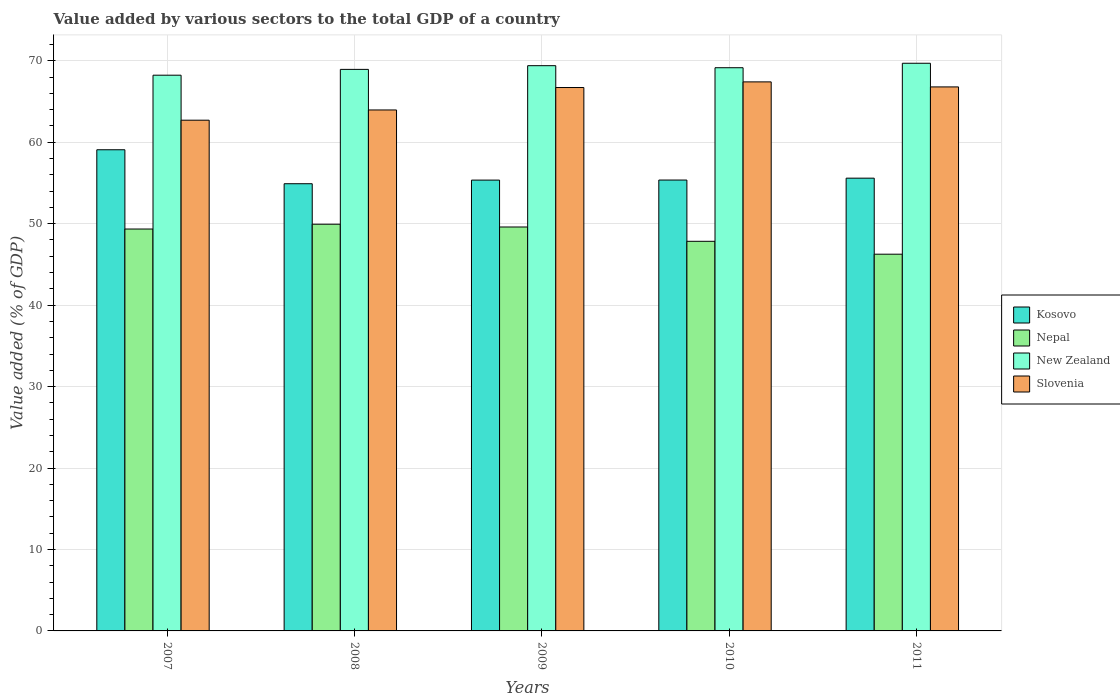How many different coloured bars are there?
Offer a terse response. 4. Are the number of bars per tick equal to the number of legend labels?
Your answer should be compact. Yes. How many bars are there on the 3rd tick from the left?
Your response must be concise. 4. What is the label of the 1st group of bars from the left?
Your answer should be very brief. 2007. In how many cases, is the number of bars for a given year not equal to the number of legend labels?
Your response must be concise. 0. What is the value added by various sectors to the total GDP in Nepal in 2009?
Provide a succinct answer. 49.59. Across all years, what is the maximum value added by various sectors to the total GDP in Slovenia?
Provide a short and direct response. 67.41. Across all years, what is the minimum value added by various sectors to the total GDP in Kosovo?
Your response must be concise. 54.91. In which year was the value added by various sectors to the total GDP in Kosovo maximum?
Offer a terse response. 2007. What is the total value added by various sectors to the total GDP in Slovenia in the graph?
Offer a very short reply. 327.6. What is the difference between the value added by various sectors to the total GDP in New Zealand in 2007 and that in 2010?
Offer a terse response. -0.92. What is the difference between the value added by various sectors to the total GDP in Kosovo in 2007 and the value added by various sectors to the total GDP in Nepal in 2009?
Make the answer very short. 9.48. What is the average value added by various sectors to the total GDP in Nepal per year?
Make the answer very short. 48.59. In the year 2009, what is the difference between the value added by various sectors to the total GDP in Nepal and value added by various sectors to the total GDP in Slovenia?
Offer a terse response. -17.12. In how many years, is the value added by various sectors to the total GDP in Slovenia greater than 60 %?
Make the answer very short. 5. What is the ratio of the value added by various sectors to the total GDP in Kosovo in 2008 to that in 2010?
Keep it short and to the point. 0.99. Is the value added by various sectors to the total GDP in Nepal in 2007 less than that in 2009?
Your answer should be very brief. Yes. Is the difference between the value added by various sectors to the total GDP in Nepal in 2010 and 2011 greater than the difference between the value added by various sectors to the total GDP in Slovenia in 2010 and 2011?
Your answer should be compact. Yes. What is the difference between the highest and the second highest value added by various sectors to the total GDP in Slovenia?
Your answer should be very brief. 0.62. What is the difference between the highest and the lowest value added by various sectors to the total GDP in Kosovo?
Your answer should be very brief. 4.17. In how many years, is the value added by various sectors to the total GDP in Kosovo greater than the average value added by various sectors to the total GDP in Kosovo taken over all years?
Your answer should be very brief. 1. What does the 1st bar from the left in 2009 represents?
Offer a terse response. Kosovo. What does the 3rd bar from the right in 2007 represents?
Give a very brief answer. Nepal. Is it the case that in every year, the sum of the value added by various sectors to the total GDP in Slovenia and value added by various sectors to the total GDP in Kosovo is greater than the value added by various sectors to the total GDP in New Zealand?
Make the answer very short. Yes. What is the difference between two consecutive major ticks on the Y-axis?
Keep it short and to the point. 10. Does the graph contain any zero values?
Offer a very short reply. No. Does the graph contain grids?
Your answer should be compact. Yes. Where does the legend appear in the graph?
Ensure brevity in your answer.  Center right. How many legend labels are there?
Offer a very short reply. 4. How are the legend labels stacked?
Offer a very short reply. Vertical. What is the title of the graph?
Make the answer very short. Value added by various sectors to the total GDP of a country. What is the label or title of the Y-axis?
Your answer should be compact. Value added (% of GDP). What is the Value added (% of GDP) in Kosovo in 2007?
Give a very brief answer. 59.08. What is the Value added (% of GDP) in Nepal in 2007?
Your response must be concise. 49.35. What is the Value added (% of GDP) of New Zealand in 2007?
Keep it short and to the point. 68.23. What is the Value added (% of GDP) in Slovenia in 2007?
Make the answer very short. 62.71. What is the Value added (% of GDP) of Kosovo in 2008?
Your answer should be compact. 54.91. What is the Value added (% of GDP) in Nepal in 2008?
Keep it short and to the point. 49.94. What is the Value added (% of GDP) in New Zealand in 2008?
Provide a short and direct response. 68.95. What is the Value added (% of GDP) of Slovenia in 2008?
Your answer should be very brief. 63.96. What is the Value added (% of GDP) of Kosovo in 2009?
Your response must be concise. 55.35. What is the Value added (% of GDP) in Nepal in 2009?
Your response must be concise. 49.59. What is the Value added (% of GDP) of New Zealand in 2009?
Provide a succinct answer. 69.4. What is the Value added (% of GDP) of Slovenia in 2009?
Give a very brief answer. 66.72. What is the Value added (% of GDP) in Kosovo in 2010?
Ensure brevity in your answer.  55.36. What is the Value added (% of GDP) of Nepal in 2010?
Provide a short and direct response. 47.84. What is the Value added (% of GDP) in New Zealand in 2010?
Provide a succinct answer. 69.15. What is the Value added (% of GDP) of Slovenia in 2010?
Your answer should be compact. 67.41. What is the Value added (% of GDP) of Kosovo in 2011?
Ensure brevity in your answer.  55.59. What is the Value added (% of GDP) in Nepal in 2011?
Give a very brief answer. 46.26. What is the Value added (% of GDP) in New Zealand in 2011?
Keep it short and to the point. 69.7. What is the Value added (% of GDP) in Slovenia in 2011?
Give a very brief answer. 66.79. Across all years, what is the maximum Value added (% of GDP) of Kosovo?
Provide a short and direct response. 59.08. Across all years, what is the maximum Value added (% of GDP) of Nepal?
Provide a short and direct response. 49.94. Across all years, what is the maximum Value added (% of GDP) of New Zealand?
Your response must be concise. 69.7. Across all years, what is the maximum Value added (% of GDP) in Slovenia?
Offer a terse response. 67.41. Across all years, what is the minimum Value added (% of GDP) of Kosovo?
Ensure brevity in your answer.  54.91. Across all years, what is the minimum Value added (% of GDP) in Nepal?
Your answer should be very brief. 46.26. Across all years, what is the minimum Value added (% of GDP) of New Zealand?
Make the answer very short. 68.23. Across all years, what is the minimum Value added (% of GDP) of Slovenia?
Make the answer very short. 62.71. What is the total Value added (% of GDP) in Kosovo in the graph?
Provide a succinct answer. 280.29. What is the total Value added (% of GDP) of Nepal in the graph?
Your answer should be compact. 242.97. What is the total Value added (% of GDP) of New Zealand in the graph?
Provide a succinct answer. 345.43. What is the total Value added (% of GDP) in Slovenia in the graph?
Provide a succinct answer. 327.6. What is the difference between the Value added (% of GDP) of Kosovo in 2007 and that in 2008?
Give a very brief answer. 4.17. What is the difference between the Value added (% of GDP) in Nepal in 2007 and that in 2008?
Offer a very short reply. -0.59. What is the difference between the Value added (% of GDP) of New Zealand in 2007 and that in 2008?
Give a very brief answer. -0.71. What is the difference between the Value added (% of GDP) in Slovenia in 2007 and that in 2008?
Offer a very short reply. -1.26. What is the difference between the Value added (% of GDP) of Kosovo in 2007 and that in 2009?
Provide a succinct answer. 3.73. What is the difference between the Value added (% of GDP) in Nepal in 2007 and that in 2009?
Give a very brief answer. -0.25. What is the difference between the Value added (% of GDP) of New Zealand in 2007 and that in 2009?
Provide a succinct answer. -1.17. What is the difference between the Value added (% of GDP) in Slovenia in 2007 and that in 2009?
Provide a short and direct response. -4.01. What is the difference between the Value added (% of GDP) of Kosovo in 2007 and that in 2010?
Your answer should be compact. 3.72. What is the difference between the Value added (% of GDP) in Nepal in 2007 and that in 2010?
Offer a very short reply. 1.51. What is the difference between the Value added (% of GDP) of New Zealand in 2007 and that in 2010?
Your answer should be compact. -0.92. What is the difference between the Value added (% of GDP) of Slovenia in 2007 and that in 2010?
Provide a succinct answer. -4.7. What is the difference between the Value added (% of GDP) of Kosovo in 2007 and that in 2011?
Offer a terse response. 3.49. What is the difference between the Value added (% of GDP) in Nepal in 2007 and that in 2011?
Make the answer very short. 3.09. What is the difference between the Value added (% of GDP) of New Zealand in 2007 and that in 2011?
Offer a terse response. -1.46. What is the difference between the Value added (% of GDP) in Slovenia in 2007 and that in 2011?
Keep it short and to the point. -4.09. What is the difference between the Value added (% of GDP) of Kosovo in 2008 and that in 2009?
Provide a short and direct response. -0.45. What is the difference between the Value added (% of GDP) in Nepal in 2008 and that in 2009?
Provide a short and direct response. 0.34. What is the difference between the Value added (% of GDP) in New Zealand in 2008 and that in 2009?
Ensure brevity in your answer.  -0.45. What is the difference between the Value added (% of GDP) in Slovenia in 2008 and that in 2009?
Your response must be concise. -2.75. What is the difference between the Value added (% of GDP) in Kosovo in 2008 and that in 2010?
Your response must be concise. -0.45. What is the difference between the Value added (% of GDP) in Nepal in 2008 and that in 2010?
Give a very brief answer. 2.1. What is the difference between the Value added (% of GDP) of New Zealand in 2008 and that in 2010?
Make the answer very short. -0.2. What is the difference between the Value added (% of GDP) in Slovenia in 2008 and that in 2010?
Keep it short and to the point. -3.45. What is the difference between the Value added (% of GDP) of Kosovo in 2008 and that in 2011?
Keep it short and to the point. -0.68. What is the difference between the Value added (% of GDP) in Nepal in 2008 and that in 2011?
Give a very brief answer. 3.68. What is the difference between the Value added (% of GDP) in New Zealand in 2008 and that in 2011?
Provide a short and direct response. -0.75. What is the difference between the Value added (% of GDP) of Slovenia in 2008 and that in 2011?
Offer a terse response. -2.83. What is the difference between the Value added (% of GDP) in Kosovo in 2009 and that in 2010?
Make the answer very short. -0.01. What is the difference between the Value added (% of GDP) in Nepal in 2009 and that in 2010?
Give a very brief answer. 1.76. What is the difference between the Value added (% of GDP) of New Zealand in 2009 and that in 2010?
Your response must be concise. 0.25. What is the difference between the Value added (% of GDP) in Slovenia in 2009 and that in 2010?
Provide a succinct answer. -0.69. What is the difference between the Value added (% of GDP) of Kosovo in 2009 and that in 2011?
Keep it short and to the point. -0.24. What is the difference between the Value added (% of GDP) of Nepal in 2009 and that in 2011?
Provide a short and direct response. 3.34. What is the difference between the Value added (% of GDP) of New Zealand in 2009 and that in 2011?
Offer a terse response. -0.3. What is the difference between the Value added (% of GDP) of Slovenia in 2009 and that in 2011?
Your answer should be compact. -0.08. What is the difference between the Value added (% of GDP) of Kosovo in 2010 and that in 2011?
Provide a short and direct response. -0.23. What is the difference between the Value added (% of GDP) of Nepal in 2010 and that in 2011?
Provide a succinct answer. 1.58. What is the difference between the Value added (% of GDP) of New Zealand in 2010 and that in 2011?
Offer a terse response. -0.55. What is the difference between the Value added (% of GDP) in Slovenia in 2010 and that in 2011?
Keep it short and to the point. 0.62. What is the difference between the Value added (% of GDP) in Kosovo in 2007 and the Value added (% of GDP) in Nepal in 2008?
Your answer should be very brief. 9.14. What is the difference between the Value added (% of GDP) in Kosovo in 2007 and the Value added (% of GDP) in New Zealand in 2008?
Offer a very short reply. -9.87. What is the difference between the Value added (% of GDP) in Kosovo in 2007 and the Value added (% of GDP) in Slovenia in 2008?
Provide a succinct answer. -4.89. What is the difference between the Value added (% of GDP) of Nepal in 2007 and the Value added (% of GDP) of New Zealand in 2008?
Your answer should be very brief. -19.6. What is the difference between the Value added (% of GDP) in Nepal in 2007 and the Value added (% of GDP) in Slovenia in 2008?
Make the answer very short. -14.62. What is the difference between the Value added (% of GDP) of New Zealand in 2007 and the Value added (% of GDP) of Slovenia in 2008?
Keep it short and to the point. 4.27. What is the difference between the Value added (% of GDP) in Kosovo in 2007 and the Value added (% of GDP) in Nepal in 2009?
Provide a short and direct response. 9.48. What is the difference between the Value added (% of GDP) of Kosovo in 2007 and the Value added (% of GDP) of New Zealand in 2009?
Keep it short and to the point. -10.32. What is the difference between the Value added (% of GDP) in Kosovo in 2007 and the Value added (% of GDP) in Slovenia in 2009?
Your answer should be very brief. -7.64. What is the difference between the Value added (% of GDP) in Nepal in 2007 and the Value added (% of GDP) in New Zealand in 2009?
Offer a terse response. -20.06. What is the difference between the Value added (% of GDP) in Nepal in 2007 and the Value added (% of GDP) in Slovenia in 2009?
Your answer should be very brief. -17.37. What is the difference between the Value added (% of GDP) of New Zealand in 2007 and the Value added (% of GDP) of Slovenia in 2009?
Give a very brief answer. 1.51. What is the difference between the Value added (% of GDP) of Kosovo in 2007 and the Value added (% of GDP) of Nepal in 2010?
Provide a succinct answer. 11.24. What is the difference between the Value added (% of GDP) of Kosovo in 2007 and the Value added (% of GDP) of New Zealand in 2010?
Keep it short and to the point. -10.07. What is the difference between the Value added (% of GDP) of Kosovo in 2007 and the Value added (% of GDP) of Slovenia in 2010?
Your answer should be compact. -8.33. What is the difference between the Value added (% of GDP) in Nepal in 2007 and the Value added (% of GDP) in New Zealand in 2010?
Keep it short and to the point. -19.8. What is the difference between the Value added (% of GDP) of Nepal in 2007 and the Value added (% of GDP) of Slovenia in 2010?
Provide a short and direct response. -18.07. What is the difference between the Value added (% of GDP) of New Zealand in 2007 and the Value added (% of GDP) of Slovenia in 2010?
Ensure brevity in your answer.  0.82. What is the difference between the Value added (% of GDP) in Kosovo in 2007 and the Value added (% of GDP) in Nepal in 2011?
Your answer should be compact. 12.82. What is the difference between the Value added (% of GDP) of Kosovo in 2007 and the Value added (% of GDP) of New Zealand in 2011?
Offer a very short reply. -10.62. What is the difference between the Value added (% of GDP) in Kosovo in 2007 and the Value added (% of GDP) in Slovenia in 2011?
Give a very brief answer. -7.72. What is the difference between the Value added (% of GDP) of Nepal in 2007 and the Value added (% of GDP) of New Zealand in 2011?
Offer a terse response. -20.35. What is the difference between the Value added (% of GDP) in Nepal in 2007 and the Value added (% of GDP) in Slovenia in 2011?
Ensure brevity in your answer.  -17.45. What is the difference between the Value added (% of GDP) of New Zealand in 2007 and the Value added (% of GDP) of Slovenia in 2011?
Your answer should be compact. 1.44. What is the difference between the Value added (% of GDP) in Kosovo in 2008 and the Value added (% of GDP) in Nepal in 2009?
Offer a very short reply. 5.31. What is the difference between the Value added (% of GDP) in Kosovo in 2008 and the Value added (% of GDP) in New Zealand in 2009?
Give a very brief answer. -14.49. What is the difference between the Value added (% of GDP) in Kosovo in 2008 and the Value added (% of GDP) in Slovenia in 2009?
Make the answer very short. -11.81. What is the difference between the Value added (% of GDP) of Nepal in 2008 and the Value added (% of GDP) of New Zealand in 2009?
Provide a succinct answer. -19.46. What is the difference between the Value added (% of GDP) in Nepal in 2008 and the Value added (% of GDP) in Slovenia in 2009?
Give a very brief answer. -16.78. What is the difference between the Value added (% of GDP) in New Zealand in 2008 and the Value added (% of GDP) in Slovenia in 2009?
Your answer should be very brief. 2.23. What is the difference between the Value added (% of GDP) in Kosovo in 2008 and the Value added (% of GDP) in Nepal in 2010?
Your response must be concise. 7.07. What is the difference between the Value added (% of GDP) of Kosovo in 2008 and the Value added (% of GDP) of New Zealand in 2010?
Ensure brevity in your answer.  -14.24. What is the difference between the Value added (% of GDP) of Kosovo in 2008 and the Value added (% of GDP) of Slovenia in 2010?
Offer a terse response. -12.51. What is the difference between the Value added (% of GDP) in Nepal in 2008 and the Value added (% of GDP) in New Zealand in 2010?
Your answer should be compact. -19.21. What is the difference between the Value added (% of GDP) of Nepal in 2008 and the Value added (% of GDP) of Slovenia in 2010?
Make the answer very short. -17.48. What is the difference between the Value added (% of GDP) of New Zealand in 2008 and the Value added (% of GDP) of Slovenia in 2010?
Provide a short and direct response. 1.53. What is the difference between the Value added (% of GDP) in Kosovo in 2008 and the Value added (% of GDP) in Nepal in 2011?
Ensure brevity in your answer.  8.65. What is the difference between the Value added (% of GDP) in Kosovo in 2008 and the Value added (% of GDP) in New Zealand in 2011?
Your response must be concise. -14.79. What is the difference between the Value added (% of GDP) of Kosovo in 2008 and the Value added (% of GDP) of Slovenia in 2011?
Offer a terse response. -11.89. What is the difference between the Value added (% of GDP) in Nepal in 2008 and the Value added (% of GDP) in New Zealand in 2011?
Your response must be concise. -19.76. What is the difference between the Value added (% of GDP) of Nepal in 2008 and the Value added (% of GDP) of Slovenia in 2011?
Provide a succinct answer. -16.86. What is the difference between the Value added (% of GDP) of New Zealand in 2008 and the Value added (% of GDP) of Slovenia in 2011?
Offer a terse response. 2.15. What is the difference between the Value added (% of GDP) of Kosovo in 2009 and the Value added (% of GDP) of Nepal in 2010?
Keep it short and to the point. 7.52. What is the difference between the Value added (% of GDP) in Kosovo in 2009 and the Value added (% of GDP) in New Zealand in 2010?
Offer a very short reply. -13.8. What is the difference between the Value added (% of GDP) in Kosovo in 2009 and the Value added (% of GDP) in Slovenia in 2010?
Your answer should be very brief. -12.06. What is the difference between the Value added (% of GDP) in Nepal in 2009 and the Value added (% of GDP) in New Zealand in 2010?
Give a very brief answer. -19.56. What is the difference between the Value added (% of GDP) in Nepal in 2009 and the Value added (% of GDP) in Slovenia in 2010?
Ensure brevity in your answer.  -17.82. What is the difference between the Value added (% of GDP) in New Zealand in 2009 and the Value added (% of GDP) in Slovenia in 2010?
Your response must be concise. 1.99. What is the difference between the Value added (% of GDP) of Kosovo in 2009 and the Value added (% of GDP) of Nepal in 2011?
Your response must be concise. 9.1. What is the difference between the Value added (% of GDP) of Kosovo in 2009 and the Value added (% of GDP) of New Zealand in 2011?
Your answer should be very brief. -14.35. What is the difference between the Value added (% of GDP) in Kosovo in 2009 and the Value added (% of GDP) in Slovenia in 2011?
Ensure brevity in your answer.  -11.44. What is the difference between the Value added (% of GDP) in Nepal in 2009 and the Value added (% of GDP) in New Zealand in 2011?
Ensure brevity in your answer.  -20.1. What is the difference between the Value added (% of GDP) of Nepal in 2009 and the Value added (% of GDP) of Slovenia in 2011?
Your answer should be compact. -17.2. What is the difference between the Value added (% of GDP) of New Zealand in 2009 and the Value added (% of GDP) of Slovenia in 2011?
Keep it short and to the point. 2.61. What is the difference between the Value added (% of GDP) in Kosovo in 2010 and the Value added (% of GDP) in Nepal in 2011?
Offer a terse response. 9.11. What is the difference between the Value added (% of GDP) in Kosovo in 2010 and the Value added (% of GDP) in New Zealand in 2011?
Offer a very short reply. -14.34. What is the difference between the Value added (% of GDP) in Kosovo in 2010 and the Value added (% of GDP) in Slovenia in 2011?
Keep it short and to the point. -11.43. What is the difference between the Value added (% of GDP) of Nepal in 2010 and the Value added (% of GDP) of New Zealand in 2011?
Ensure brevity in your answer.  -21.86. What is the difference between the Value added (% of GDP) in Nepal in 2010 and the Value added (% of GDP) in Slovenia in 2011?
Offer a terse response. -18.96. What is the difference between the Value added (% of GDP) in New Zealand in 2010 and the Value added (% of GDP) in Slovenia in 2011?
Offer a very short reply. 2.36. What is the average Value added (% of GDP) of Kosovo per year?
Offer a terse response. 56.06. What is the average Value added (% of GDP) of Nepal per year?
Offer a very short reply. 48.59. What is the average Value added (% of GDP) in New Zealand per year?
Keep it short and to the point. 69.09. What is the average Value added (% of GDP) of Slovenia per year?
Your response must be concise. 65.52. In the year 2007, what is the difference between the Value added (% of GDP) of Kosovo and Value added (% of GDP) of Nepal?
Keep it short and to the point. 9.73. In the year 2007, what is the difference between the Value added (% of GDP) of Kosovo and Value added (% of GDP) of New Zealand?
Offer a terse response. -9.16. In the year 2007, what is the difference between the Value added (% of GDP) of Kosovo and Value added (% of GDP) of Slovenia?
Provide a short and direct response. -3.63. In the year 2007, what is the difference between the Value added (% of GDP) in Nepal and Value added (% of GDP) in New Zealand?
Offer a very short reply. -18.89. In the year 2007, what is the difference between the Value added (% of GDP) in Nepal and Value added (% of GDP) in Slovenia?
Offer a very short reply. -13.36. In the year 2007, what is the difference between the Value added (% of GDP) in New Zealand and Value added (% of GDP) in Slovenia?
Your answer should be compact. 5.53. In the year 2008, what is the difference between the Value added (% of GDP) of Kosovo and Value added (% of GDP) of Nepal?
Offer a very short reply. 4.97. In the year 2008, what is the difference between the Value added (% of GDP) of Kosovo and Value added (% of GDP) of New Zealand?
Provide a short and direct response. -14.04. In the year 2008, what is the difference between the Value added (% of GDP) in Kosovo and Value added (% of GDP) in Slovenia?
Make the answer very short. -9.06. In the year 2008, what is the difference between the Value added (% of GDP) of Nepal and Value added (% of GDP) of New Zealand?
Your response must be concise. -19.01. In the year 2008, what is the difference between the Value added (% of GDP) of Nepal and Value added (% of GDP) of Slovenia?
Give a very brief answer. -14.03. In the year 2008, what is the difference between the Value added (% of GDP) of New Zealand and Value added (% of GDP) of Slovenia?
Make the answer very short. 4.98. In the year 2009, what is the difference between the Value added (% of GDP) in Kosovo and Value added (% of GDP) in Nepal?
Provide a short and direct response. 5.76. In the year 2009, what is the difference between the Value added (% of GDP) in Kosovo and Value added (% of GDP) in New Zealand?
Give a very brief answer. -14.05. In the year 2009, what is the difference between the Value added (% of GDP) in Kosovo and Value added (% of GDP) in Slovenia?
Offer a very short reply. -11.37. In the year 2009, what is the difference between the Value added (% of GDP) in Nepal and Value added (% of GDP) in New Zealand?
Make the answer very short. -19.81. In the year 2009, what is the difference between the Value added (% of GDP) of Nepal and Value added (% of GDP) of Slovenia?
Provide a short and direct response. -17.12. In the year 2009, what is the difference between the Value added (% of GDP) in New Zealand and Value added (% of GDP) in Slovenia?
Offer a terse response. 2.68. In the year 2010, what is the difference between the Value added (% of GDP) of Kosovo and Value added (% of GDP) of Nepal?
Offer a terse response. 7.52. In the year 2010, what is the difference between the Value added (% of GDP) of Kosovo and Value added (% of GDP) of New Zealand?
Keep it short and to the point. -13.79. In the year 2010, what is the difference between the Value added (% of GDP) of Kosovo and Value added (% of GDP) of Slovenia?
Make the answer very short. -12.05. In the year 2010, what is the difference between the Value added (% of GDP) in Nepal and Value added (% of GDP) in New Zealand?
Your answer should be very brief. -21.31. In the year 2010, what is the difference between the Value added (% of GDP) in Nepal and Value added (% of GDP) in Slovenia?
Offer a terse response. -19.58. In the year 2010, what is the difference between the Value added (% of GDP) of New Zealand and Value added (% of GDP) of Slovenia?
Provide a short and direct response. 1.74. In the year 2011, what is the difference between the Value added (% of GDP) of Kosovo and Value added (% of GDP) of Nepal?
Provide a succinct answer. 9.34. In the year 2011, what is the difference between the Value added (% of GDP) of Kosovo and Value added (% of GDP) of New Zealand?
Ensure brevity in your answer.  -14.11. In the year 2011, what is the difference between the Value added (% of GDP) in Kosovo and Value added (% of GDP) in Slovenia?
Your response must be concise. -11.2. In the year 2011, what is the difference between the Value added (% of GDP) of Nepal and Value added (% of GDP) of New Zealand?
Make the answer very short. -23.44. In the year 2011, what is the difference between the Value added (% of GDP) of Nepal and Value added (% of GDP) of Slovenia?
Offer a very short reply. -20.54. In the year 2011, what is the difference between the Value added (% of GDP) in New Zealand and Value added (% of GDP) in Slovenia?
Provide a short and direct response. 2.9. What is the ratio of the Value added (% of GDP) of Kosovo in 2007 to that in 2008?
Make the answer very short. 1.08. What is the ratio of the Value added (% of GDP) of Nepal in 2007 to that in 2008?
Keep it short and to the point. 0.99. What is the ratio of the Value added (% of GDP) in Slovenia in 2007 to that in 2008?
Keep it short and to the point. 0.98. What is the ratio of the Value added (% of GDP) in Kosovo in 2007 to that in 2009?
Your answer should be compact. 1.07. What is the ratio of the Value added (% of GDP) of New Zealand in 2007 to that in 2009?
Provide a short and direct response. 0.98. What is the ratio of the Value added (% of GDP) in Slovenia in 2007 to that in 2009?
Offer a very short reply. 0.94. What is the ratio of the Value added (% of GDP) in Kosovo in 2007 to that in 2010?
Provide a short and direct response. 1.07. What is the ratio of the Value added (% of GDP) in Nepal in 2007 to that in 2010?
Keep it short and to the point. 1.03. What is the ratio of the Value added (% of GDP) of New Zealand in 2007 to that in 2010?
Offer a terse response. 0.99. What is the ratio of the Value added (% of GDP) in Slovenia in 2007 to that in 2010?
Make the answer very short. 0.93. What is the ratio of the Value added (% of GDP) in Kosovo in 2007 to that in 2011?
Keep it short and to the point. 1.06. What is the ratio of the Value added (% of GDP) in Nepal in 2007 to that in 2011?
Your response must be concise. 1.07. What is the ratio of the Value added (% of GDP) in New Zealand in 2007 to that in 2011?
Give a very brief answer. 0.98. What is the ratio of the Value added (% of GDP) of Slovenia in 2007 to that in 2011?
Offer a very short reply. 0.94. What is the ratio of the Value added (% of GDP) of New Zealand in 2008 to that in 2009?
Your answer should be very brief. 0.99. What is the ratio of the Value added (% of GDP) of Slovenia in 2008 to that in 2009?
Your answer should be very brief. 0.96. What is the ratio of the Value added (% of GDP) in Nepal in 2008 to that in 2010?
Ensure brevity in your answer.  1.04. What is the ratio of the Value added (% of GDP) in Slovenia in 2008 to that in 2010?
Your response must be concise. 0.95. What is the ratio of the Value added (% of GDP) in Kosovo in 2008 to that in 2011?
Ensure brevity in your answer.  0.99. What is the ratio of the Value added (% of GDP) in Nepal in 2008 to that in 2011?
Your answer should be compact. 1.08. What is the ratio of the Value added (% of GDP) of New Zealand in 2008 to that in 2011?
Keep it short and to the point. 0.99. What is the ratio of the Value added (% of GDP) in Slovenia in 2008 to that in 2011?
Offer a terse response. 0.96. What is the ratio of the Value added (% of GDP) of Kosovo in 2009 to that in 2010?
Offer a very short reply. 1. What is the ratio of the Value added (% of GDP) in Nepal in 2009 to that in 2010?
Your answer should be very brief. 1.04. What is the ratio of the Value added (% of GDP) of New Zealand in 2009 to that in 2010?
Your response must be concise. 1. What is the ratio of the Value added (% of GDP) of Nepal in 2009 to that in 2011?
Provide a short and direct response. 1.07. What is the ratio of the Value added (% of GDP) of Nepal in 2010 to that in 2011?
Provide a short and direct response. 1.03. What is the ratio of the Value added (% of GDP) of Slovenia in 2010 to that in 2011?
Your answer should be very brief. 1.01. What is the difference between the highest and the second highest Value added (% of GDP) in Kosovo?
Keep it short and to the point. 3.49. What is the difference between the highest and the second highest Value added (% of GDP) in Nepal?
Keep it short and to the point. 0.34. What is the difference between the highest and the second highest Value added (% of GDP) in New Zealand?
Your response must be concise. 0.3. What is the difference between the highest and the second highest Value added (% of GDP) of Slovenia?
Your answer should be very brief. 0.62. What is the difference between the highest and the lowest Value added (% of GDP) of Kosovo?
Your answer should be very brief. 4.17. What is the difference between the highest and the lowest Value added (% of GDP) in Nepal?
Provide a succinct answer. 3.68. What is the difference between the highest and the lowest Value added (% of GDP) in New Zealand?
Make the answer very short. 1.46. What is the difference between the highest and the lowest Value added (% of GDP) in Slovenia?
Make the answer very short. 4.7. 